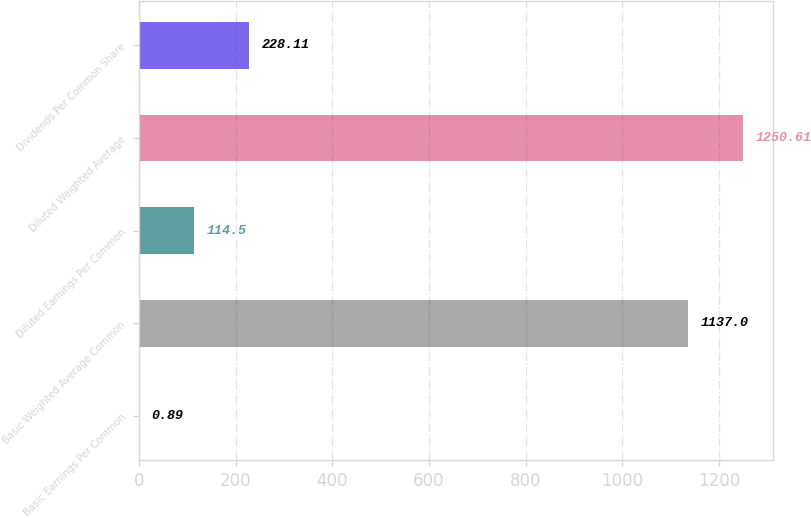Convert chart to OTSL. <chart><loc_0><loc_0><loc_500><loc_500><bar_chart><fcel>Basic Earnings Per Common<fcel>Basic Weighted Average Common<fcel>Diluted Earnings Per Common<fcel>Diluted Weighted Average<fcel>Dividends Per Common Share<nl><fcel>0.89<fcel>1137<fcel>114.5<fcel>1250.61<fcel>228.11<nl></chart> 